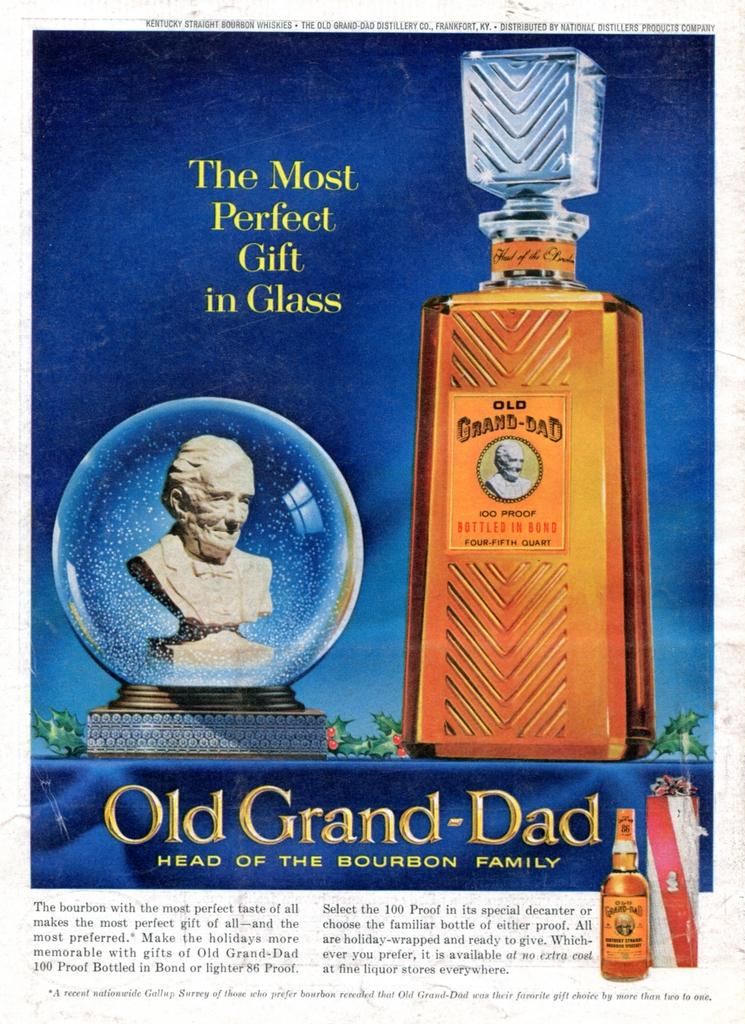<image>
Summarize the visual content of the image. Page showing a statue next to a giant bottle of Old Grand-Dad. 